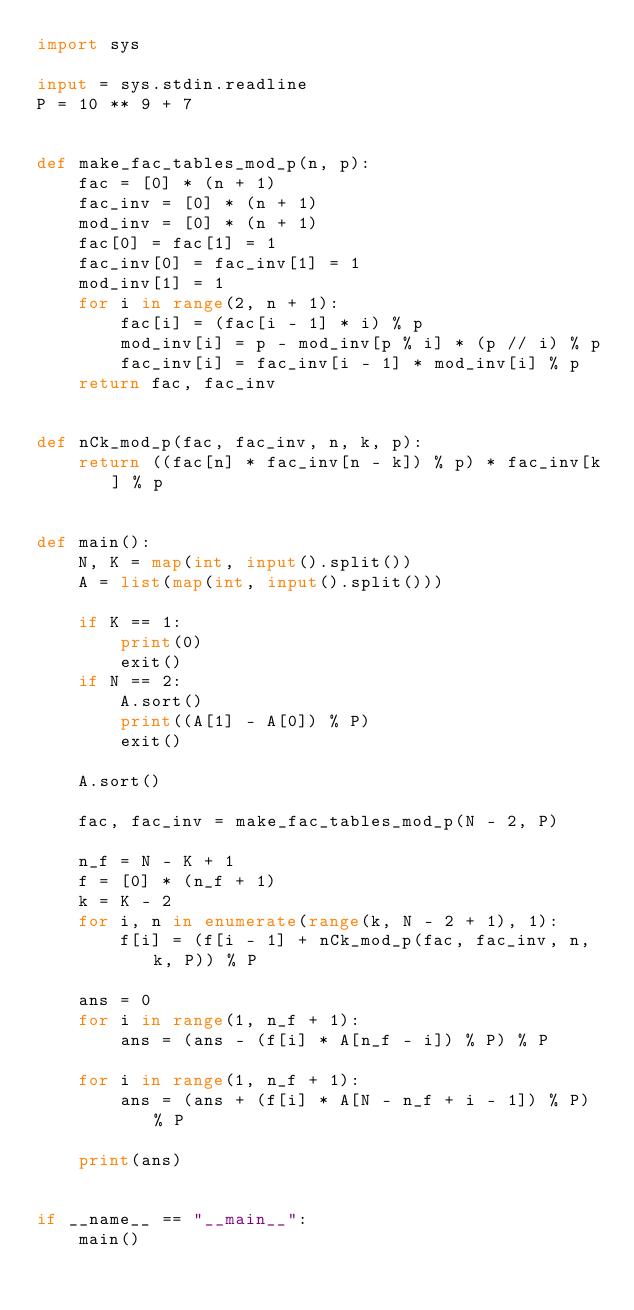<code> <loc_0><loc_0><loc_500><loc_500><_Python_>import sys

input = sys.stdin.readline
P = 10 ** 9 + 7


def make_fac_tables_mod_p(n, p):
    fac = [0] * (n + 1)
    fac_inv = [0] * (n + 1)
    mod_inv = [0] * (n + 1)
    fac[0] = fac[1] = 1
    fac_inv[0] = fac_inv[1] = 1
    mod_inv[1] = 1
    for i in range(2, n + 1):
        fac[i] = (fac[i - 1] * i) % p
        mod_inv[i] = p - mod_inv[p % i] * (p // i) % p
        fac_inv[i] = fac_inv[i - 1] * mod_inv[i] % p
    return fac, fac_inv


def nCk_mod_p(fac, fac_inv, n, k, p):
    return ((fac[n] * fac_inv[n - k]) % p) * fac_inv[k] % p


def main():
    N, K = map(int, input().split())
    A = list(map(int, input().split()))

    if K == 1:
        print(0)
        exit()
    if N == 2:
        A.sort()
        print((A[1] - A[0]) % P)
        exit()

    A.sort()

    fac, fac_inv = make_fac_tables_mod_p(N - 2, P)

    n_f = N - K + 1
    f = [0] * (n_f + 1)
    k = K - 2
    for i, n in enumerate(range(k, N - 2 + 1), 1):
        f[i] = (f[i - 1] + nCk_mod_p(fac, fac_inv, n, k, P)) % P

    ans = 0
    for i in range(1, n_f + 1):
        ans = (ans - (f[i] * A[n_f - i]) % P) % P

    for i in range(1, n_f + 1):
        ans = (ans + (f[i] * A[N - n_f + i - 1]) % P) % P

    print(ans)


if __name__ == "__main__":
    main()
</code> 